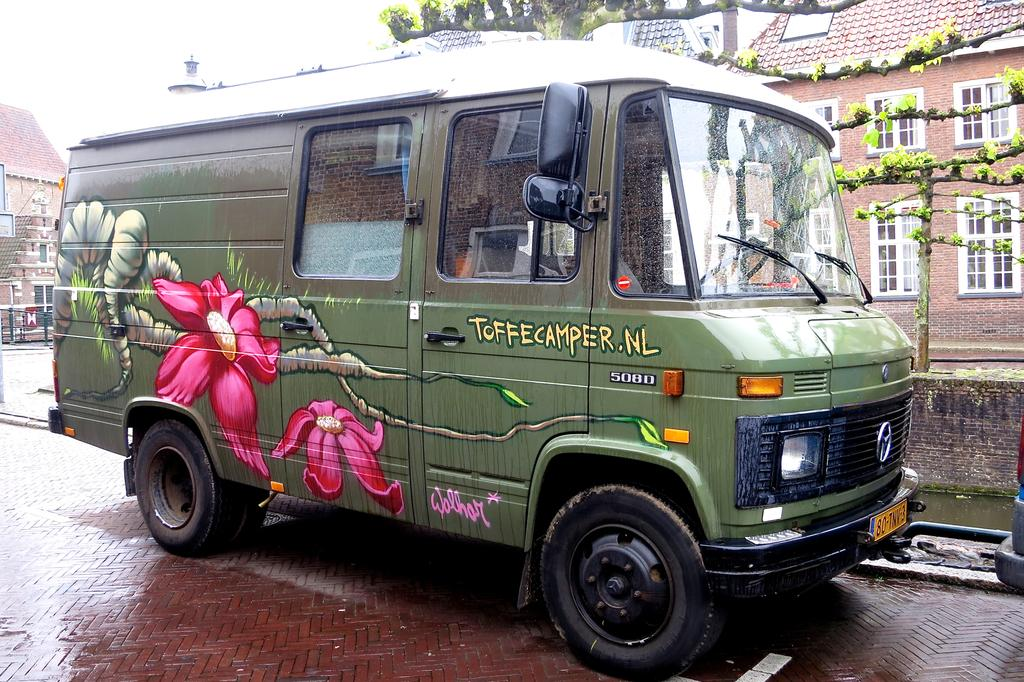Provide a one-sentence caption for the provided image. Green and petite truck for ToffeeCamper parked outdoors. 